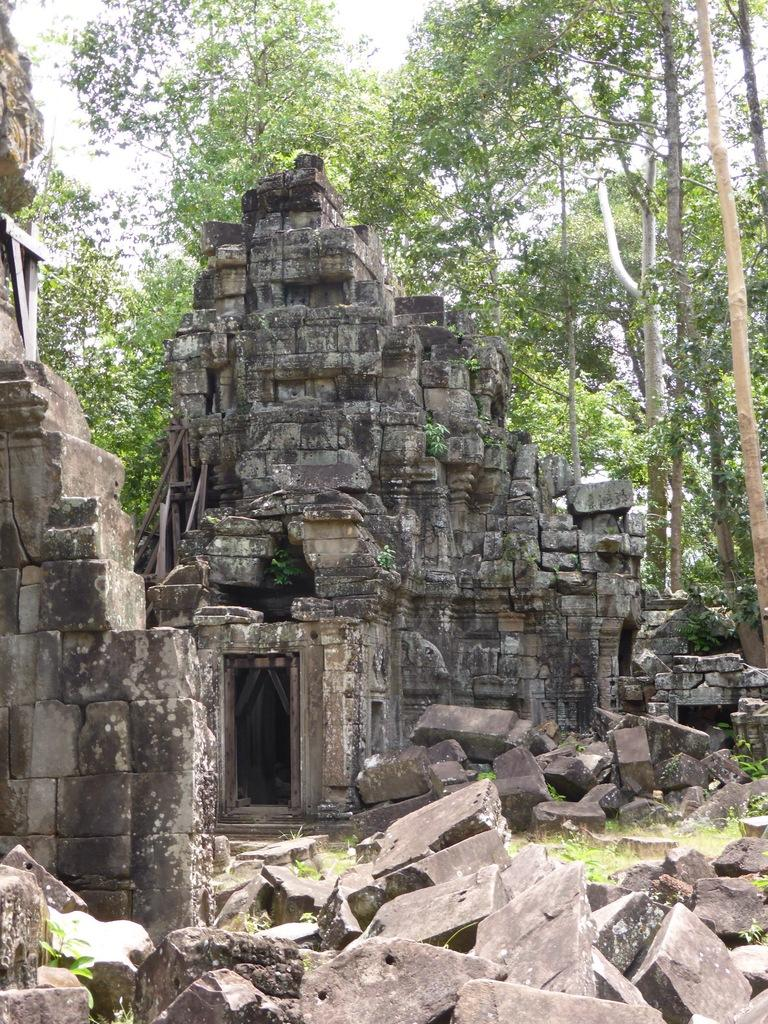What type of natural elements can be seen in the image? There are stones and grass visible in the image. What type of man-made structures are present in the image? Ancient architecture is present in the image. What can be seen in the background of the image? There are trees and the sky visible in the background of the image. What type of cloud can be seen in the image? There is no cloud present in the image; only trees and the sky are visible in the background. What does the crook use to paste the stones together in the image? There is no crook or paste present in the image; it features ancient architecture, stones, grass, trees, and the sky. 